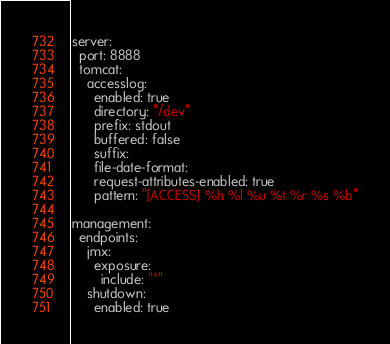<code> <loc_0><loc_0><loc_500><loc_500><_YAML_>server:
  port: 8888
  tomcat:
    accesslog:
      enabled: true
      directory: "/dev"
      prefix: stdout
      buffered: false
      suffix:
      file-date-format:
      request-attributes-enabled: true
      pattern: "[ACCESS] %h %l %u %t %r %s %b"

management:
  endpoints:
    jmx:
      exposure:
        include: "*"
    shutdown:
      enabled: true
</code> 